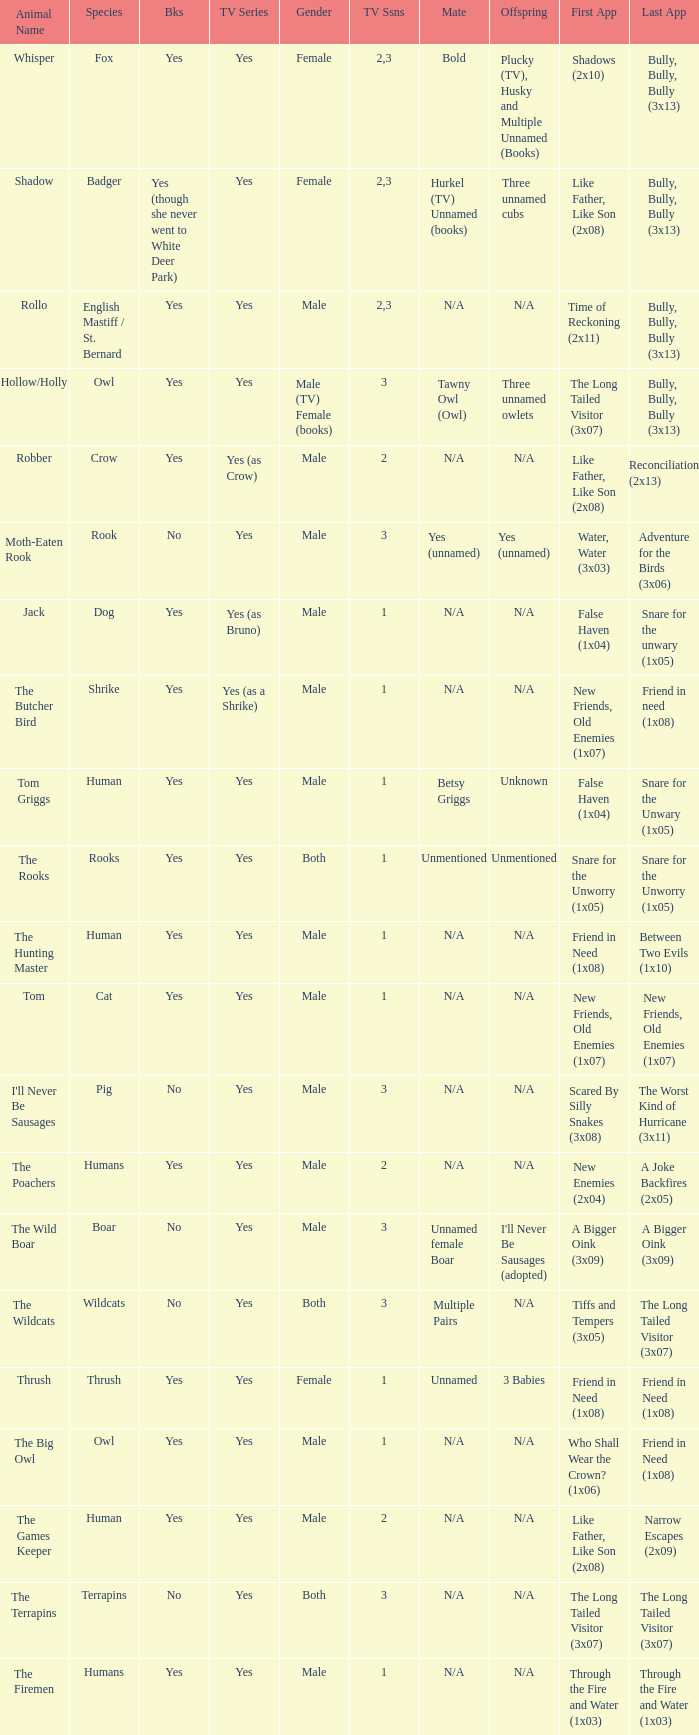What presentation contains a boar? Yes. 